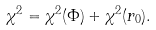<formula> <loc_0><loc_0><loc_500><loc_500>\chi ^ { 2 } = \chi ^ { 2 } ( \Phi ) + \chi ^ { 2 } ( r _ { 0 } ) .</formula> 